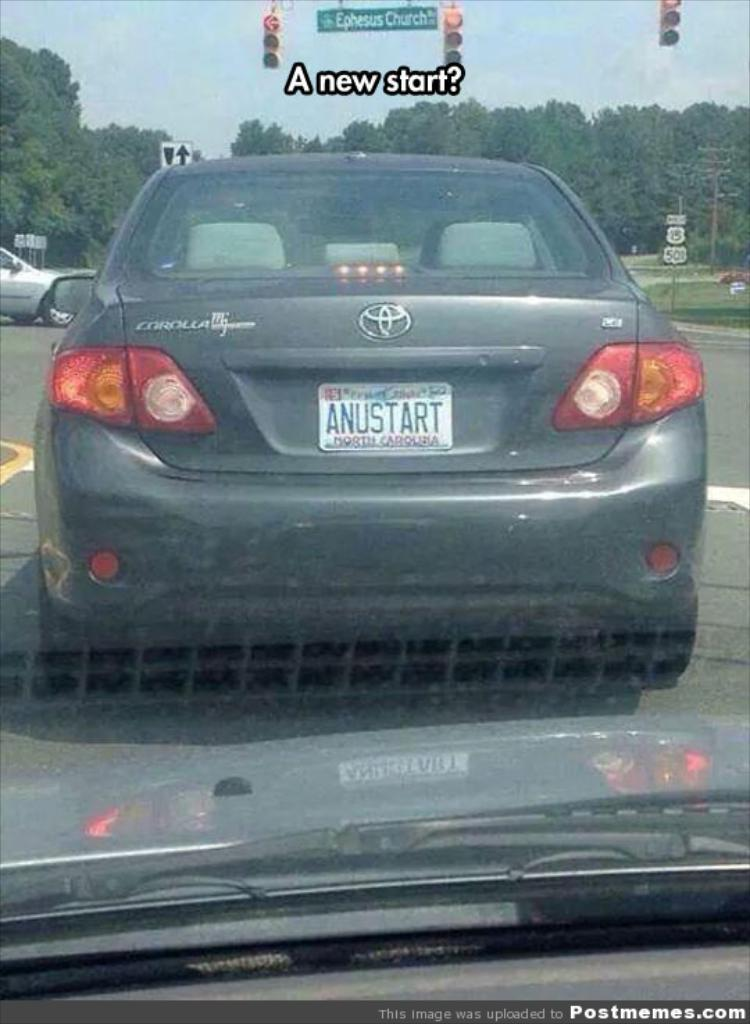<image>
Give a short and clear explanation of the subsequent image. A grey Toyota car that says Corolla on the back is at a yellow light. 